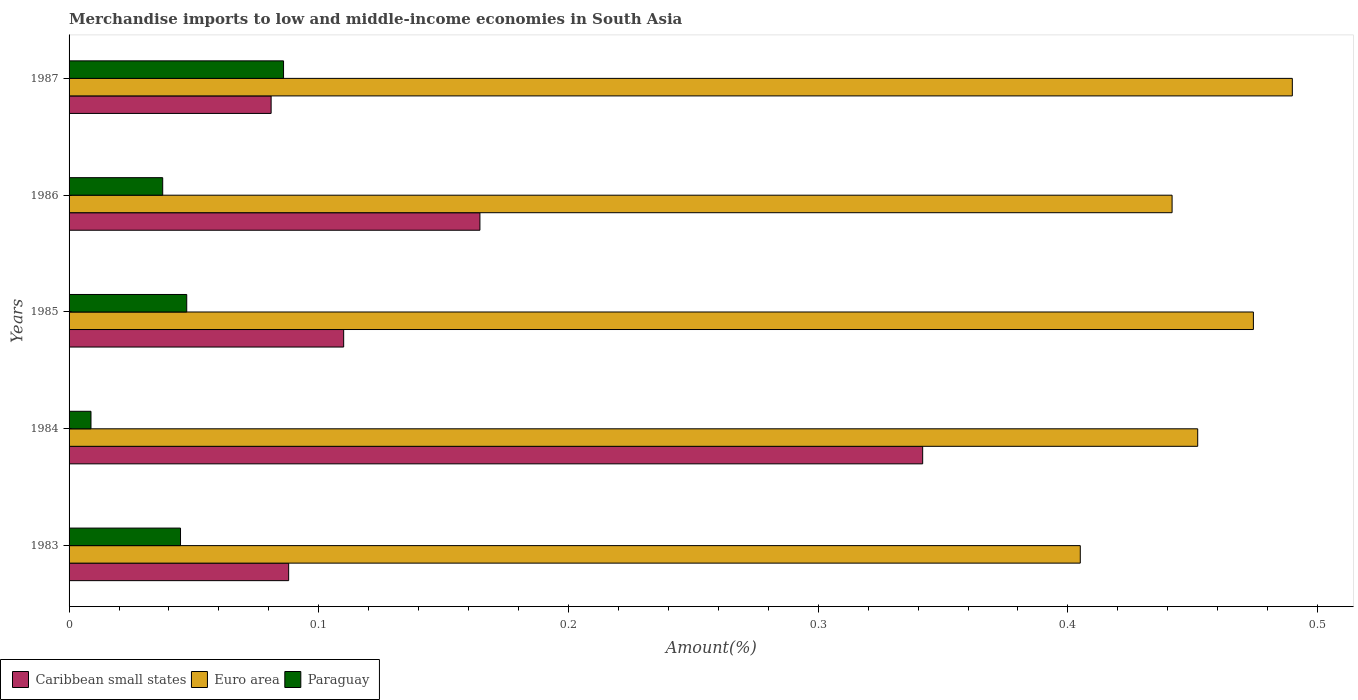Are the number of bars per tick equal to the number of legend labels?
Ensure brevity in your answer.  Yes. Are the number of bars on each tick of the Y-axis equal?
Offer a terse response. Yes. How many bars are there on the 3rd tick from the bottom?
Your answer should be very brief. 3. What is the label of the 2nd group of bars from the top?
Your answer should be compact. 1986. In how many cases, is the number of bars for a given year not equal to the number of legend labels?
Provide a succinct answer. 0. What is the percentage of amount earned from merchandise imports in Caribbean small states in 1984?
Your response must be concise. 0.34. Across all years, what is the maximum percentage of amount earned from merchandise imports in Euro area?
Your answer should be very brief. 0.49. Across all years, what is the minimum percentage of amount earned from merchandise imports in Caribbean small states?
Provide a succinct answer. 0.08. What is the total percentage of amount earned from merchandise imports in Caribbean small states in the graph?
Give a very brief answer. 0.79. What is the difference between the percentage of amount earned from merchandise imports in Paraguay in 1985 and that in 1986?
Provide a short and direct response. 0.01. What is the difference between the percentage of amount earned from merchandise imports in Euro area in 1987 and the percentage of amount earned from merchandise imports in Caribbean small states in 1984?
Your answer should be compact. 0.15. What is the average percentage of amount earned from merchandise imports in Euro area per year?
Provide a short and direct response. 0.45. In the year 1983, what is the difference between the percentage of amount earned from merchandise imports in Paraguay and percentage of amount earned from merchandise imports in Euro area?
Your response must be concise. -0.36. What is the ratio of the percentage of amount earned from merchandise imports in Euro area in 1983 to that in 1984?
Offer a very short reply. 0.9. Is the difference between the percentage of amount earned from merchandise imports in Paraguay in 1985 and 1986 greater than the difference between the percentage of amount earned from merchandise imports in Euro area in 1985 and 1986?
Your answer should be very brief. No. What is the difference between the highest and the second highest percentage of amount earned from merchandise imports in Caribbean small states?
Your answer should be compact. 0.18. What is the difference between the highest and the lowest percentage of amount earned from merchandise imports in Caribbean small states?
Your response must be concise. 0.26. In how many years, is the percentage of amount earned from merchandise imports in Euro area greater than the average percentage of amount earned from merchandise imports in Euro area taken over all years?
Ensure brevity in your answer.  2. Is the sum of the percentage of amount earned from merchandise imports in Euro area in 1985 and 1987 greater than the maximum percentage of amount earned from merchandise imports in Paraguay across all years?
Give a very brief answer. Yes. What does the 2nd bar from the top in 1986 represents?
Offer a terse response. Euro area. What does the 1st bar from the bottom in 1986 represents?
Offer a very short reply. Caribbean small states. Is it the case that in every year, the sum of the percentage of amount earned from merchandise imports in Euro area and percentage of amount earned from merchandise imports in Paraguay is greater than the percentage of amount earned from merchandise imports in Caribbean small states?
Your answer should be very brief. Yes. Does the graph contain any zero values?
Keep it short and to the point. No. How are the legend labels stacked?
Offer a terse response. Horizontal. What is the title of the graph?
Give a very brief answer. Merchandise imports to low and middle-income economies in South Asia. What is the label or title of the X-axis?
Make the answer very short. Amount(%). What is the Amount(%) in Caribbean small states in 1983?
Your answer should be very brief. 0.09. What is the Amount(%) in Euro area in 1983?
Your answer should be compact. 0.4. What is the Amount(%) of Paraguay in 1983?
Your answer should be very brief. 0.04. What is the Amount(%) of Caribbean small states in 1984?
Make the answer very short. 0.34. What is the Amount(%) of Euro area in 1984?
Provide a succinct answer. 0.45. What is the Amount(%) in Paraguay in 1984?
Make the answer very short. 0.01. What is the Amount(%) of Caribbean small states in 1985?
Offer a very short reply. 0.11. What is the Amount(%) in Euro area in 1985?
Offer a very short reply. 0.47. What is the Amount(%) of Paraguay in 1985?
Offer a very short reply. 0.05. What is the Amount(%) of Caribbean small states in 1986?
Ensure brevity in your answer.  0.16. What is the Amount(%) of Euro area in 1986?
Offer a terse response. 0.44. What is the Amount(%) in Paraguay in 1986?
Your response must be concise. 0.04. What is the Amount(%) of Caribbean small states in 1987?
Offer a very short reply. 0.08. What is the Amount(%) in Euro area in 1987?
Ensure brevity in your answer.  0.49. What is the Amount(%) of Paraguay in 1987?
Provide a short and direct response. 0.09. Across all years, what is the maximum Amount(%) of Caribbean small states?
Give a very brief answer. 0.34. Across all years, what is the maximum Amount(%) in Euro area?
Your answer should be compact. 0.49. Across all years, what is the maximum Amount(%) in Paraguay?
Ensure brevity in your answer.  0.09. Across all years, what is the minimum Amount(%) in Caribbean small states?
Offer a terse response. 0.08. Across all years, what is the minimum Amount(%) of Euro area?
Your answer should be compact. 0.4. Across all years, what is the minimum Amount(%) of Paraguay?
Ensure brevity in your answer.  0.01. What is the total Amount(%) of Caribbean small states in the graph?
Keep it short and to the point. 0.79. What is the total Amount(%) of Euro area in the graph?
Give a very brief answer. 2.26. What is the total Amount(%) in Paraguay in the graph?
Give a very brief answer. 0.22. What is the difference between the Amount(%) of Caribbean small states in 1983 and that in 1984?
Provide a succinct answer. -0.25. What is the difference between the Amount(%) in Euro area in 1983 and that in 1984?
Provide a succinct answer. -0.05. What is the difference between the Amount(%) of Paraguay in 1983 and that in 1984?
Give a very brief answer. 0.04. What is the difference between the Amount(%) of Caribbean small states in 1983 and that in 1985?
Offer a very short reply. -0.02. What is the difference between the Amount(%) in Euro area in 1983 and that in 1985?
Offer a very short reply. -0.07. What is the difference between the Amount(%) of Paraguay in 1983 and that in 1985?
Ensure brevity in your answer.  -0. What is the difference between the Amount(%) in Caribbean small states in 1983 and that in 1986?
Your answer should be very brief. -0.08. What is the difference between the Amount(%) in Euro area in 1983 and that in 1986?
Give a very brief answer. -0.04. What is the difference between the Amount(%) in Paraguay in 1983 and that in 1986?
Keep it short and to the point. 0.01. What is the difference between the Amount(%) in Caribbean small states in 1983 and that in 1987?
Offer a very short reply. 0.01. What is the difference between the Amount(%) of Euro area in 1983 and that in 1987?
Provide a succinct answer. -0.08. What is the difference between the Amount(%) in Paraguay in 1983 and that in 1987?
Offer a terse response. -0.04. What is the difference between the Amount(%) in Caribbean small states in 1984 and that in 1985?
Provide a succinct answer. 0.23. What is the difference between the Amount(%) of Euro area in 1984 and that in 1985?
Keep it short and to the point. -0.02. What is the difference between the Amount(%) of Paraguay in 1984 and that in 1985?
Give a very brief answer. -0.04. What is the difference between the Amount(%) in Caribbean small states in 1984 and that in 1986?
Give a very brief answer. 0.18. What is the difference between the Amount(%) of Euro area in 1984 and that in 1986?
Provide a succinct answer. 0.01. What is the difference between the Amount(%) of Paraguay in 1984 and that in 1986?
Provide a short and direct response. -0.03. What is the difference between the Amount(%) in Caribbean small states in 1984 and that in 1987?
Give a very brief answer. 0.26. What is the difference between the Amount(%) in Euro area in 1984 and that in 1987?
Offer a terse response. -0.04. What is the difference between the Amount(%) in Paraguay in 1984 and that in 1987?
Your answer should be compact. -0.08. What is the difference between the Amount(%) of Caribbean small states in 1985 and that in 1986?
Your answer should be very brief. -0.05. What is the difference between the Amount(%) in Euro area in 1985 and that in 1986?
Your answer should be very brief. 0.03. What is the difference between the Amount(%) of Paraguay in 1985 and that in 1986?
Give a very brief answer. 0.01. What is the difference between the Amount(%) in Caribbean small states in 1985 and that in 1987?
Offer a terse response. 0.03. What is the difference between the Amount(%) in Euro area in 1985 and that in 1987?
Keep it short and to the point. -0.02. What is the difference between the Amount(%) of Paraguay in 1985 and that in 1987?
Make the answer very short. -0.04. What is the difference between the Amount(%) in Caribbean small states in 1986 and that in 1987?
Your answer should be very brief. 0.08. What is the difference between the Amount(%) of Euro area in 1986 and that in 1987?
Offer a terse response. -0.05. What is the difference between the Amount(%) of Paraguay in 1986 and that in 1987?
Keep it short and to the point. -0.05. What is the difference between the Amount(%) of Caribbean small states in 1983 and the Amount(%) of Euro area in 1984?
Your answer should be compact. -0.36. What is the difference between the Amount(%) of Caribbean small states in 1983 and the Amount(%) of Paraguay in 1984?
Offer a terse response. 0.08. What is the difference between the Amount(%) of Euro area in 1983 and the Amount(%) of Paraguay in 1984?
Offer a very short reply. 0.4. What is the difference between the Amount(%) in Caribbean small states in 1983 and the Amount(%) in Euro area in 1985?
Make the answer very short. -0.39. What is the difference between the Amount(%) in Caribbean small states in 1983 and the Amount(%) in Paraguay in 1985?
Your response must be concise. 0.04. What is the difference between the Amount(%) in Euro area in 1983 and the Amount(%) in Paraguay in 1985?
Your answer should be very brief. 0.36. What is the difference between the Amount(%) of Caribbean small states in 1983 and the Amount(%) of Euro area in 1986?
Give a very brief answer. -0.35. What is the difference between the Amount(%) of Caribbean small states in 1983 and the Amount(%) of Paraguay in 1986?
Keep it short and to the point. 0.05. What is the difference between the Amount(%) of Euro area in 1983 and the Amount(%) of Paraguay in 1986?
Offer a very short reply. 0.37. What is the difference between the Amount(%) of Caribbean small states in 1983 and the Amount(%) of Euro area in 1987?
Your answer should be very brief. -0.4. What is the difference between the Amount(%) of Caribbean small states in 1983 and the Amount(%) of Paraguay in 1987?
Offer a terse response. 0. What is the difference between the Amount(%) in Euro area in 1983 and the Amount(%) in Paraguay in 1987?
Provide a short and direct response. 0.32. What is the difference between the Amount(%) in Caribbean small states in 1984 and the Amount(%) in Euro area in 1985?
Offer a very short reply. -0.13. What is the difference between the Amount(%) in Caribbean small states in 1984 and the Amount(%) in Paraguay in 1985?
Offer a terse response. 0.29. What is the difference between the Amount(%) of Euro area in 1984 and the Amount(%) of Paraguay in 1985?
Provide a succinct answer. 0.4. What is the difference between the Amount(%) in Caribbean small states in 1984 and the Amount(%) in Euro area in 1986?
Keep it short and to the point. -0.1. What is the difference between the Amount(%) of Caribbean small states in 1984 and the Amount(%) of Paraguay in 1986?
Keep it short and to the point. 0.3. What is the difference between the Amount(%) of Euro area in 1984 and the Amount(%) of Paraguay in 1986?
Make the answer very short. 0.41. What is the difference between the Amount(%) of Caribbean small states in 1984 and the Amount(%) of Euro area in 1987?
Offer a very short reply. -0.15. What is the difference between the Amount(%) in Caribbean small states in 1984 and the Amount(%) in Paraguay in 1987?
Give a very brief answer. 0.26. What is the difference between the Amount(%) in Euro area in 1984 and the Amount(%) in Paraguay in 1987?
Provide a succinct answer. 0.37. What is the difference between the Amount(%) in Caribbean small states in 1985 and the Amount(%) in Euro area in 1986?
Offer a terse response. -0.33. What is the difference between the Amount(%) of Caribbean small states in 1985 and the Amount(%) of Paraguay in 1986?
Provide a short and direct response. 0.07. What is the difference between the Amount(%) in Euro area in 1985 and the Amount(%) in Paraguay in 1986?
Your answer should be very brief. 0.44. What is the difference between the Amount(%) in Caribbean small states in 1985 and the Amount(%) in Euro area in 1987?
Offer a terse response. -0.38. What is the difference between the Amount(%) in Caribbean small states in 1985 and the Amount(%) in Paraguay in 1987?
Offer a very short reply. 0.02. What is the difference between the Amount(%) in Euro area in 1985 and the Amount(%) in Paraguay in 1987?
Offer a very short reply. 0.39. What is the difference between the Amount(%) in Caribbean small states in 1986 and the Amount(%) in Euro area in 1987?
Offer a very short reply. -0.33. What is the difference between the Amount(%) in Caribbean small states in 1986 and the Amount(%) in Paraguay in 1987?
Provide a succinct answer. 0.08. What is the difference between the Amount(%) in Euro area in 1986 and the Amount(%) in Paraguay in 1987?
Give a very brief answer. 0.36. What is the average Amount(%) in Caribbean small states per year?
Your answer should be very brief. 0.16. What is the average Amount(%) in Euro area per year?
Your answer should be compact. 0.45. What is the average Amount(%) in Paraguay per year?
Offer a very short reply. 0.04. In the year 1983, what is the difference between the Amount(%) in Caribbean small states and Amount(%) in Euro area?
Ensure brevity in your answer.  -0.32. In the year 1983, what is the difference between the Amount(%) in Caribbean small states and Amount(%) in Paraguay?
Provide a succinct answer. 0.04. In the year 1983, what is the difference between the Amount(%) in Euro area and Amount(%) in Paraguay?
Keep it short and to the point. 0.36. In the year 1984, what is the difference between the Amount(%) of Caribbean small states and Amount(%) of Euro area?
Your answer should be very brief. -0.11. In the year 1984, what is the difference between the Amount(%) of Caribbean small states and Amount(%) of Paraguay?
Give a very brief answer. 0.33. In the year 1984, what is the difference between the Amount(%) of Euro area and Amount(%) of Paraguay?
Give a very brief answer. 0.44. In the year 1985, what is the difference between the Amount(%) of Caribbean small states and Amount(%) of Euro area?
Keep it short and to the point. -0.36. In the year 1985, what is the difference between the Amount(%) of Caribbean small states and Amount(%) of Paraguay?
Keep it short and to the point. 0.06. In the year 1985, what is the difference between the Amount(%) in Euro area and Amount(%) in Paraguay?
Make the answer very short. 0.43. In the year 1986, what is the difference between the Amount(%) of Caribbean small states and Amount(%) of Euro area?
Give a very brief answer. -0.28. In the year 1986, what is the difference between the Amount(%) in Caribbean small states and Amount(%) in Paraguay?
Ensure brevity in your answer.  0.13. In the year 1986, what is the difference between the Amount(%) of Euro area and Amount(%) of Paraguay?
Provide a succinct answer. 0.4. In the year 1987, what is the difference between the Amount(%) in Caribbean small states and Amount(%) in Euro area?
Ensure brevity in your answer.  -0.41. In the year 1987, what is the difference between the Amount(%) in Caribbean small states and Amount(%) in Paraguay?
Keep it short and to the point. -0.01. In the year 1987, what is the difference between the Amount(%) of Euro area and Amount(%) of Paraguay?
Provide a succinct answer. 0.4. What is the ratio of the Amount(%) of Caribbean small states in 1983 to that in 1984?
Your response must be concise. 0.26. What is the ratio of the Amount(%) in Euro area in 1983 to that in 1984?
Make the answer very short. 0.9. What is the ratio of the Amount(%) of Paraguay in 1983 to that in 1984?
Offer a very short reply. 5.08. What is the ratio of the Amount(%) of Caribbean small states in 1983 to that in 1985?
Ensure brevity in your answer.  0.8. What is the ratio of the Amount(%) of Euro area in 1983 to that in 1985?
Your answer should be very brief. 0.85. What is the ratio of the Amount(%) of Paraguay in 1983 to that in 1985?
Your response must be concise. 0.95. What is the ratio of the Amount(%) in Caribbean small states in 1983 to that in 1986?
Your answer should be compact. 0.53. What is the ratio of the Amount(%) of Euro area in 1983 to that in 1986?
Offer a terse response. 0.92. What is the ratio of the Amount(%) of Paraguay in 1983 to that in 1986?
Your response must be concise. 1.19. What is the ratio of the Amount(%) of Caribbean small states in 1983 to that in 1987?
Ensure brevity in your answer.  1.09. What is the ratio of the Amount(%) of Euro area in 1983 to that in 1987?
Your response must be concise. 0.83. What is the ratio of the Amount(%) of Paraguay in 1983 to that in 1987?
Make the answer very short. 0.52. What is the ratio of the Amount(%) in Caribbean small states in 1984 to that in 1985?
Ensure brevity in your answer.  3.11. What is the ratio of the Amount(%) in Euro area in 1984 to that in 1985?
Offer a terse response. 0.95. What is the ratio of the Amount(%) in Paraguay in 1984 to that in 1985?
Ensure brevity in your answer.  0.19. What is the ratio of the Amount(%) in Caribbean small states in 1984 to that in 1986?
Your answer should be very brief. 2.08. What is the ratio of the Amount(%) of Euro area in 1984 to that in 1986?
Offer a very short reply. 1.02. What is the ratio of the Amount(%) in Paraguay in 1984 to that in 1986?
Offer a very short reply. 0.23. What is the ratio of the Amount(%) of Caribbean small states in 1984 to that in 1987?
Ensure brevity in your answer.  4.22. What is the ratio of the Amount(%) in Euro area in 1984 to that in 1987?
Your answer should be very brief. 0.92. What is the ratio of the Amount(%) of Paraguay in 1984 to that in 1987?
Provide a succinct answer. 0.1. What is the ratio of the Amount(%) in Caribbean small states in 1985 to that in 1986?
Ensure brevity in your answer.  0.67. What is the ratio of the Amount(%) in Euro area in 1985 to that in 1986?
Keep it short and to the point. 1.07. What is the ratio of the Amount(%) of Paraguay in 1985 to that in 1986?
Provide a short and direct response. 1.26. What is the ratio of the Amount(%) of Caribbean small states in 1985 to that in 1987?
Offer a terse response. 1.36. What is the ratio of the Amount(%) of Euro area in 1985 to that in 1987?
Keep it short and to the point. 0.97. What is the ratio of the Amount(%) of Paraguay in 1985 to that in 1987?
Keep it short and to the point. 0.55. What is the ratio of the Amount(%) in Caribbean small states in 1986 to that in 1987?
Your answer should be compact. 2.03. What is the ratio of the Amount(%) of Euro area in 1986 to that in 1987?
Provide a short and direct response. 0.9. What is the ratio of the Amount(%) of Paraguay in 1986 to that in 1987?
Your answer should be very brief. 0.44. What is the difference between the highest and the second highest Amount(%) of Caribbean small states?
Keep it short and to the point. 0.18. What is the difference between the highest and the second highest Amount(%) of Euro area?
Ensure brevity in your answer.  0.02. What is the difference between the highest and the second highest Amount(%) of Paraguay?
Make the answer very short. 0.04. What is the difference between the highest and the lowest Amount(%) in Caribbean small states?
Give a very brief answer. 0.26. What is the difference between the highest and the lowest Amount(%) of Euro area?
Make the answer very short. 0.08. What is the difference between the highest and the lowest Amount(%) in Paraguay?
Provide a short and direct response. 0.08. 